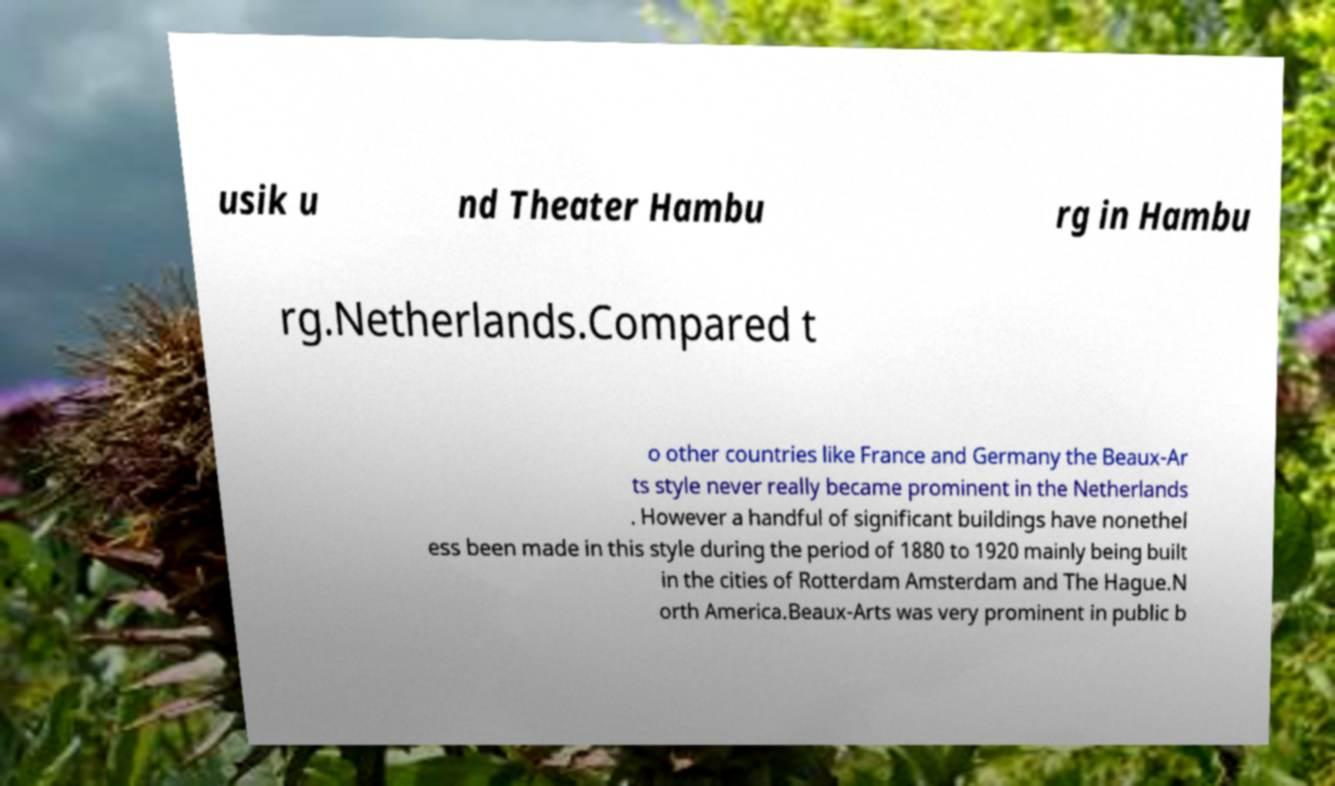Could you extract and type out the text from this image? usik u nd Theater Hambu rg in Hambu rg.Netherlands.Compared t o other countries like France and Germany the Beaux-Ar ts style never really became prominent in the Netherlands . However a handful of significant buildings have nonethel ess been made in this style during the period of 1880 to 1920 mainly being built in the cities of Rotterdam Amsterdam and The Hague.N orth America.Beaux-Arts was very prominent in public b 